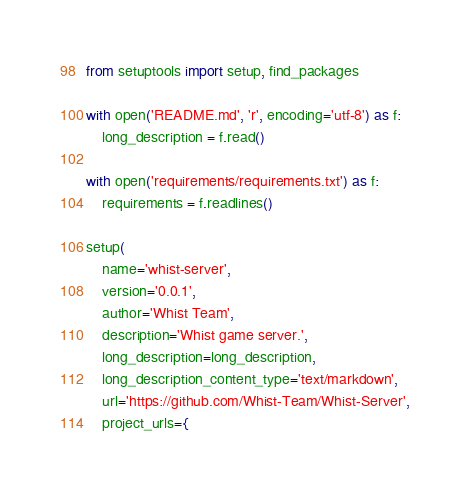Convert code to text. <code><loc_0><loc_0><loc_500><loc_500><_Python_>from setuptools import setup, find_packages

with open('README.md', 'r', encoding='utf-8') as f:
    long_description = f.read()

with open('requirements/requirements.txt') as f:
    requirements = f.readlines()

setup(
    name='whist-server',
    version='0.0.1',
    author='Whist Team',
    description='Whist game server.',
    long_description=long_description,
    long_description_content_type='text/markdown',
    url='https://github.com/Whist-Team/Whist-Server',
    project_urls={</code> 